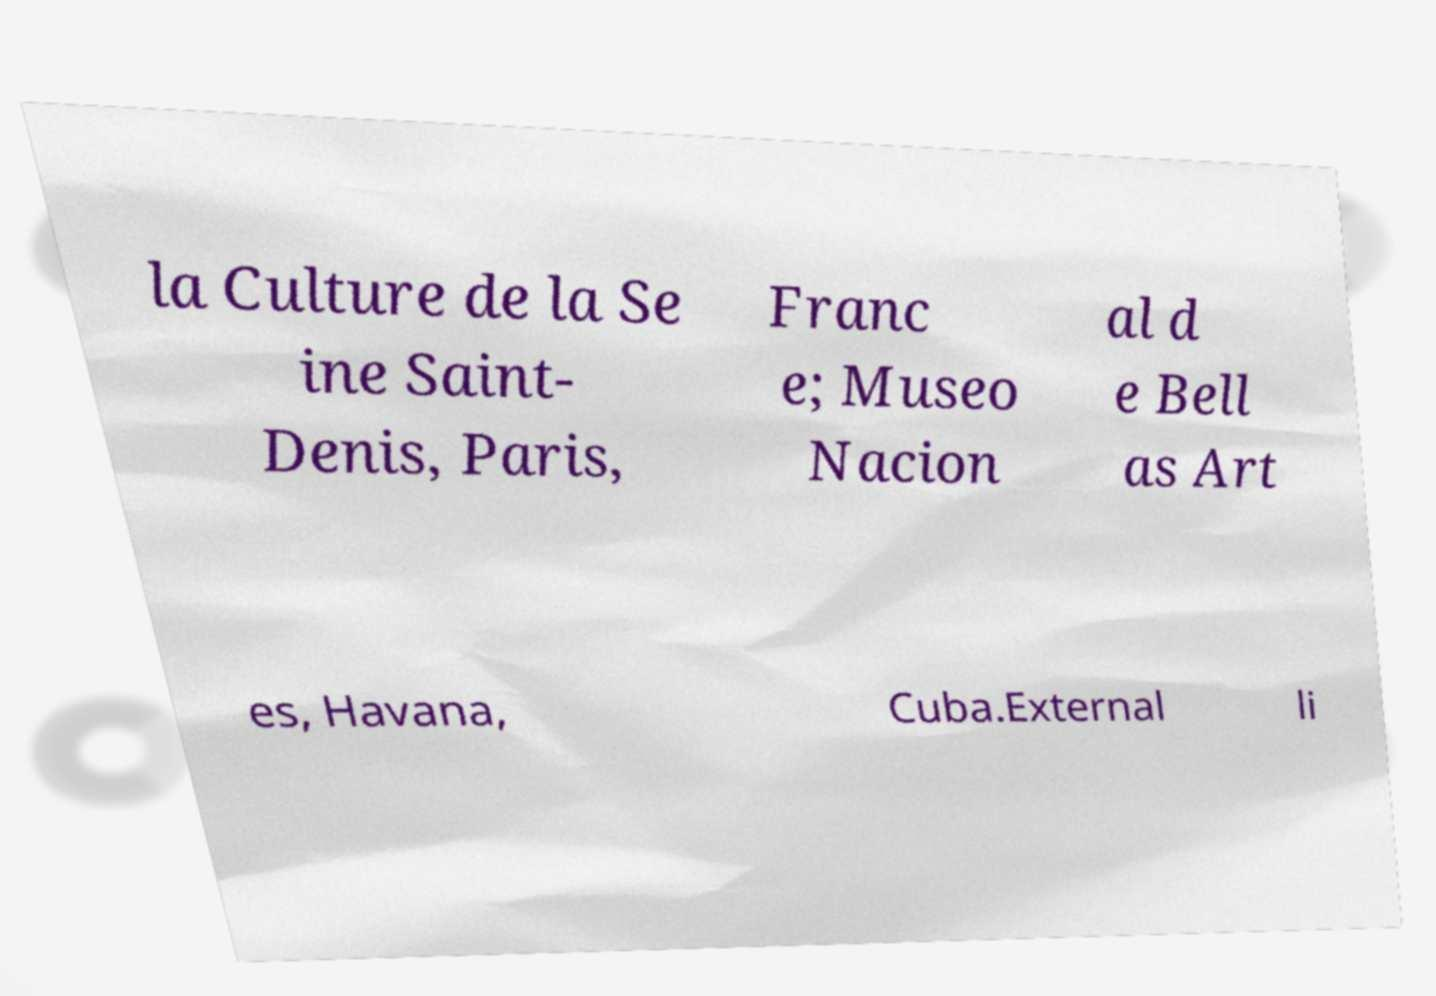I need the written content from this picture converted into text. Can you do that? la Culture de la Se ine Saint- Denis, Paris, Franc e; Museo Nacion al d e Bell as Art es, Havana, Cuba.External li 